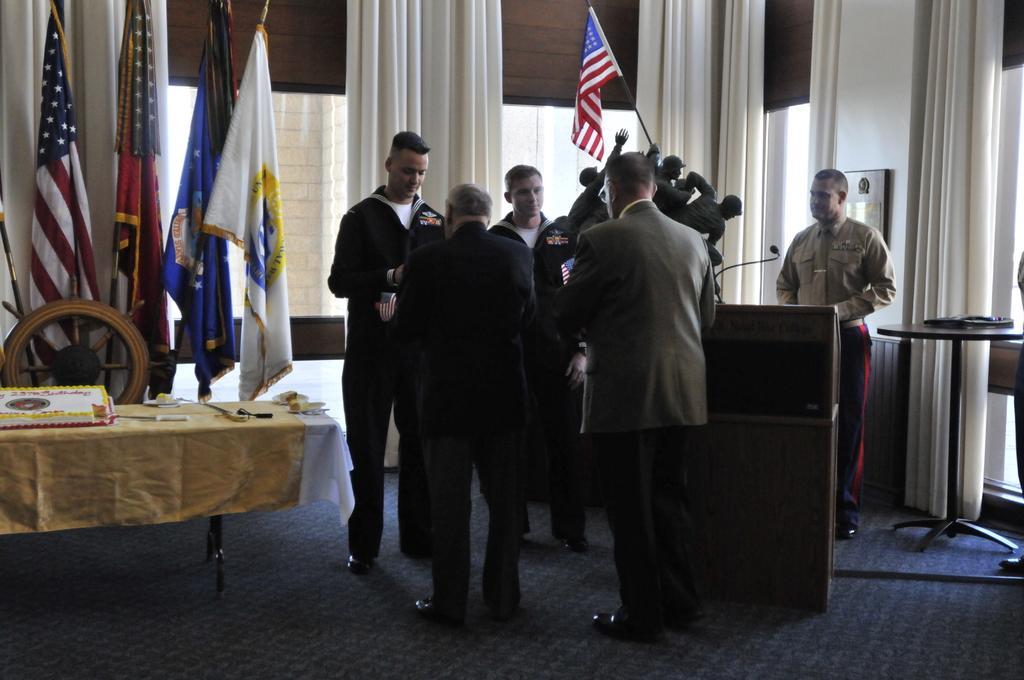Please provide a concise description of this image. There are many people standing. There is a statue with a flag. Near to them there is a podium. In the back there are curtains. On the left side there is a table. On the table there are many items. In the back there are many flags. 